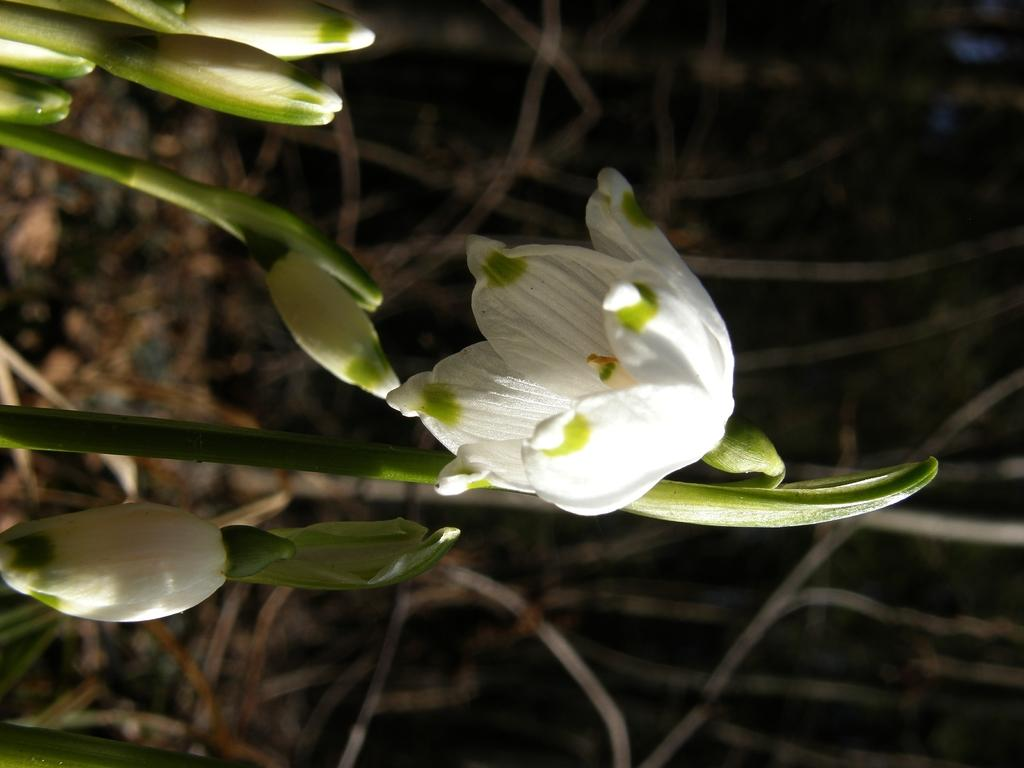What type of living organisms can be seen in the image? Plants can be seen in the image. What color are the flowers on the plants? The flowers on the plants are white. Where are the flowers located in relation to the image? The flowers are visible in the middle of the image. Can you see the eye of the twig in the image? There is no twig or eye present in the image; it features plants with white flowers. 